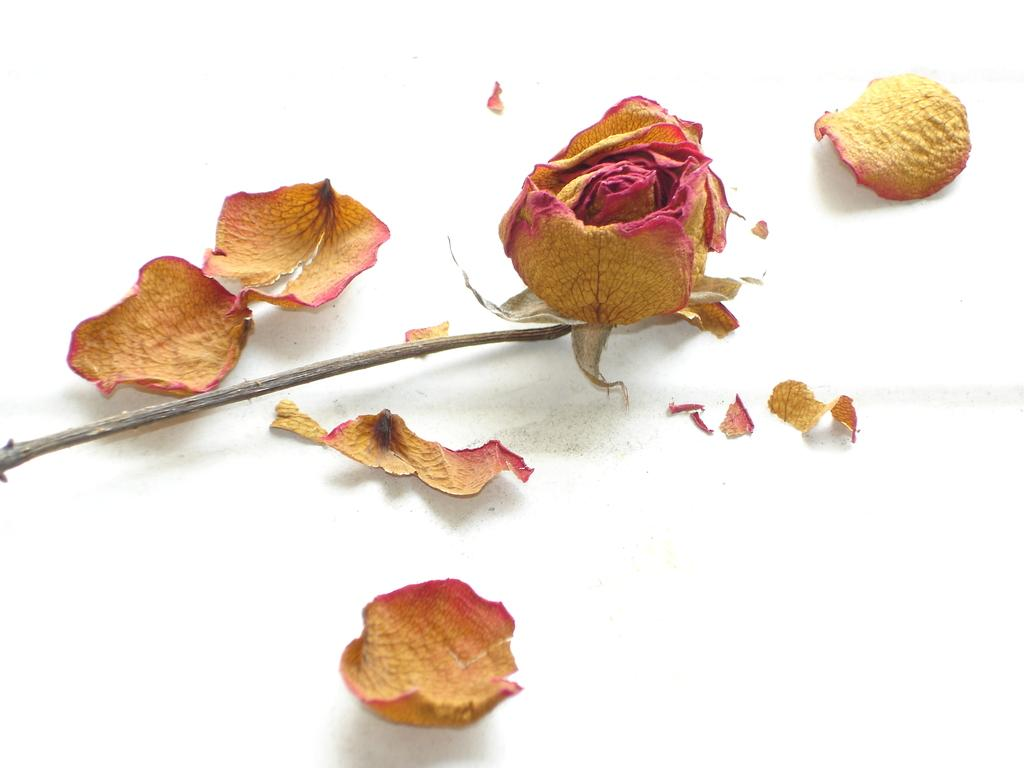What type of plant is present in the image? There is a dried flower in the image. Can you describe the dried flower's structure? The dried flower has a stem. What is the color of the object that the flower petals are on? The flower petals are on a white object in the image. What type of church is depicted in the image? There is no church present in the image; it features a dried flower with a stem and flower petals on a white object. What type of hat is the person wearing in the image? There is no person or hat present in the image; it features a dried flower with a stem and flower petals on a white object. 